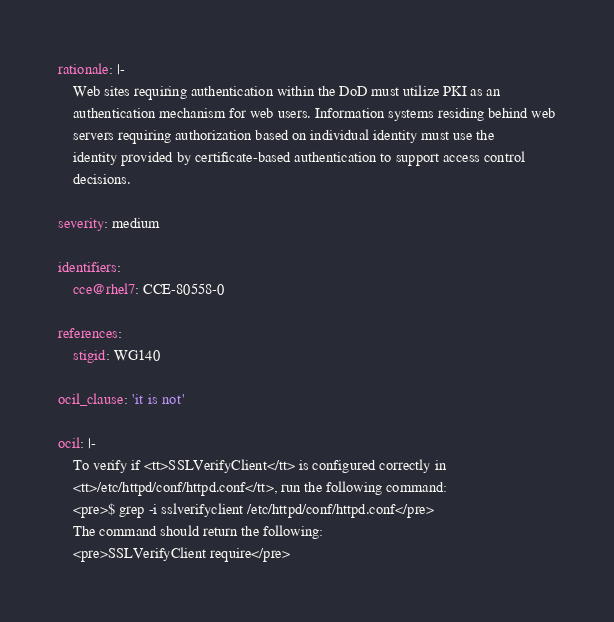Convert code to text. <code><loc_0><loc_0><loc_500><loc_500><_YAML_>rationale: |-
    Web sites requiring authentication within the DoD must utilize PKI as an
    authentication mechanism for web users. Information systems residing behind web
    servers requiring authorization based on individual identity must use the
    identity provided by certificate-based authentication to support access control
    decisions.

severity: medium

identifiers:
    cce@rhel7: CCE-80558-0

references:
    stigid: WG140

ocil_clause: 'it is not'

ocil: |-
    To verify if <tt>SSLVerifyClient</tt> is configured correctly in
    <tt>/etc/httpd/conf/httpd.conf</tt>, run the following command:
    <pre>$ grep -i sslverifyclient /etc/httpd/conf/httpd.conf</pre>
    The command should return the following:
    <pre>SSLVerifyClient require</pre>
</code> 